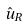Convert formula to latex. <formula><loc_0><loc_0><loc_500><loc_500>\hat { u } _ { R }</formula> 